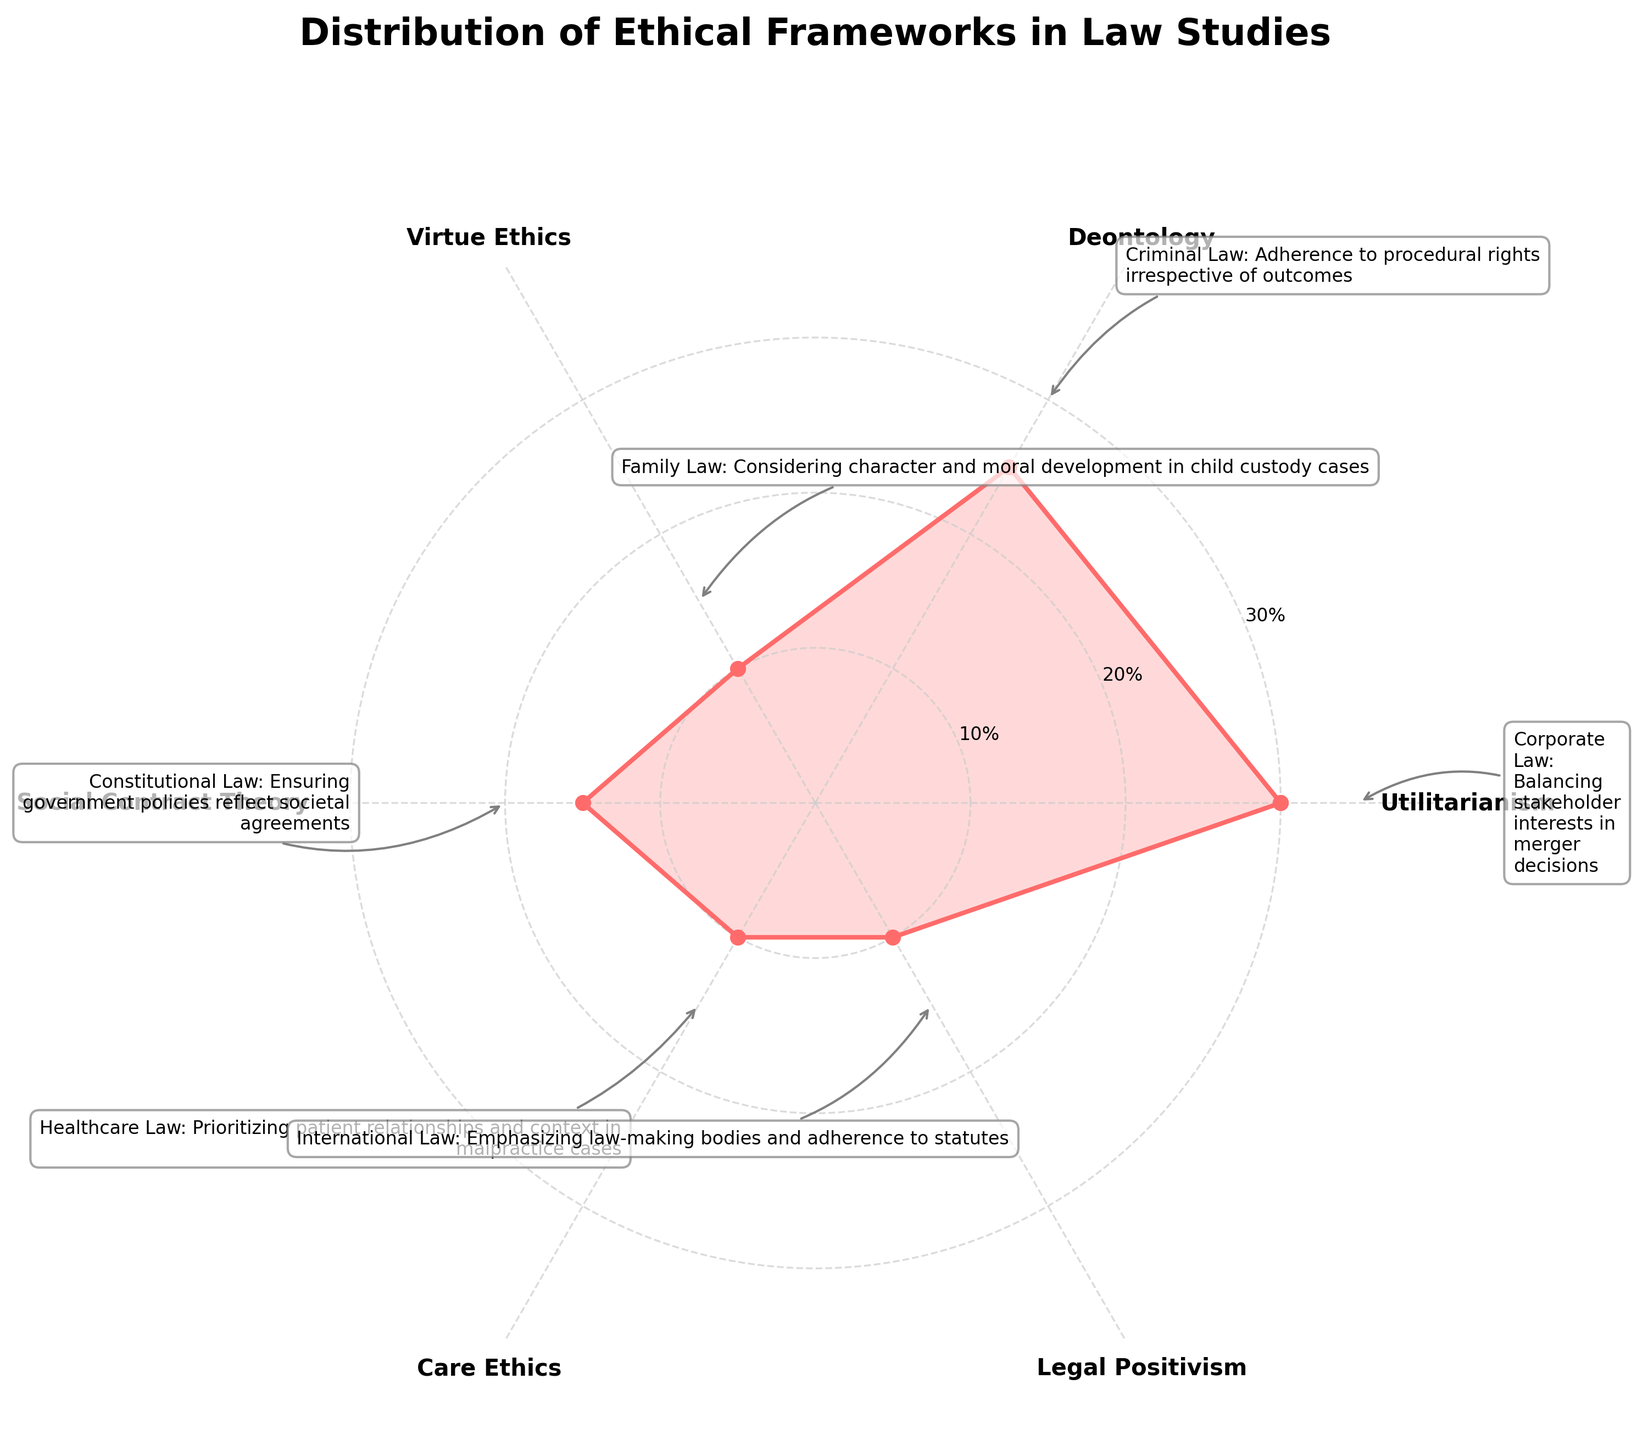What is the most commonly studied ethical framework among law students according to the chart? The chart shows that Utilitarianism has the highest percentage, which is 30%.
Answer: Utilitarianism Which ethical frameworks have equal representation in the study percentage? From the chart, Virtue Ethics, Care Ethics, and Legal Positivism each have 10% representation.
Answer: Virtue Ethics, Care Ethics, and Legal Positivism What is the combined study percentage of Deontology and Social Contract Theory? Adding the percentages of Deontology (25%) and Social Contract Theory (15%) gives 25 + 15 = 40%.
Answer: 40% Which framework has a higher percentage of study: Deontology or Social Contract Theory? The chart shows Deontology has 25%, while Social Contract Theory has 15%. Thus, Deontology has a higher percentage.
Answer: Deontology How much higher is the study percentage of Utilitarianism compared to Virtue Ethics? Utilitarianism has 30%, and Virtue Ethics has 10%. The difference is 30 - 10 = 20%.
Answer: 20% What ethical framework is tied to Healthcare Law in its real-world application? According to the annotations on the chart, Care Ethics is linked to Healthcare Law.
Answer: Care Ethics List the ethical frameworks in descending order of their study percentages. The chart shows Utilitarianism (30%), Deontology (25%), Social Contract Theory (15%), and Virtue Ethics, Care Ethics, Legal Positivism (all at 10%), so the order is: Utilitarianism, Deontology, Social Contract Theory, Virtue Ethics, Care Ethics, Legal Positivism.
Answer: Utilitarianism, Deontology, Social Contract Theory, Virtue Ethics, Care Ethics, Legal Positivism Which ethical framework is associated with Constitutional Law in its real-world application? The annotation on the chart states that Social Contract Theory is applicable in Constitutional Law.
Answer: Social Contract Theory Determine the average study percentage of all the ethical frameworks shown in the chart. Adding up all percentages: 30 + 25 + 10 + 15 + 10 + 10 = 100, then divide by the number of frameworks, 100/6 = 16.67%.
Answer: 16.67% Is the percentage of study under Legal Positivism higher, lower, or equal to that of Care Ethics? Both Legal Positivism and Care Ethics have a study percentage of 10%, so they are equal.
Answer: Equal 